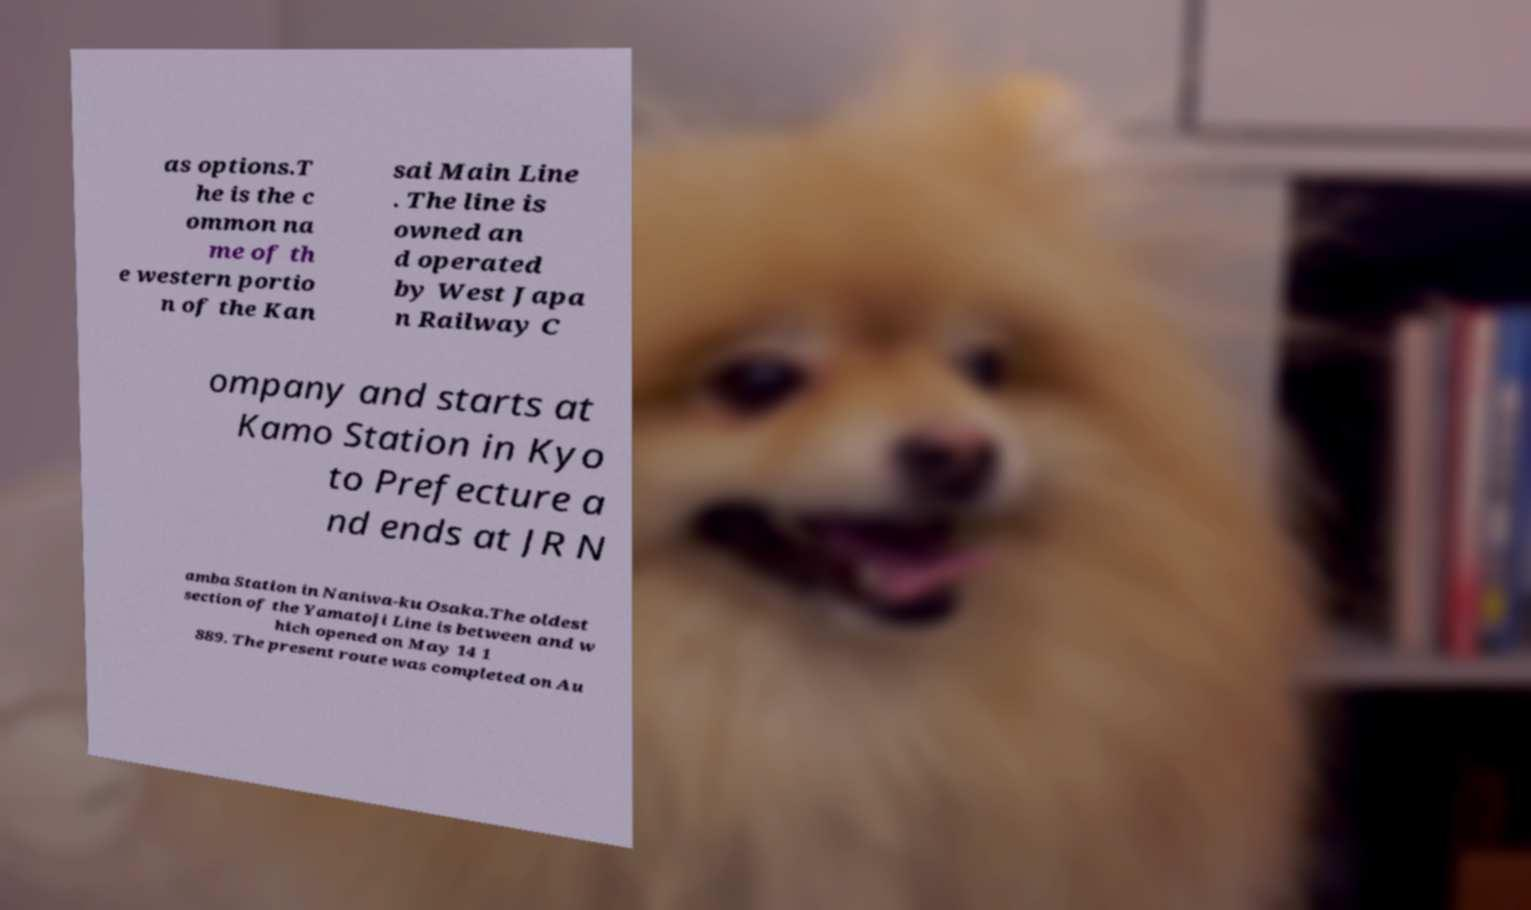What messages or text are displayed in this image? I need them in a readable, typed format. as options.T he is the c ommon na me of th e western portio n of the Kan sai Main Line . The line is owned an d operated by West Japa n Railway C ompany and starts at Kamo Station in Kyo to Prefecture a nd ends at JR N amba Station in Naniwa-ku Osaka.The oldest section of the Yamatoji Line is between and w hich opened on May 14 1 889. The present route was completed on Au 